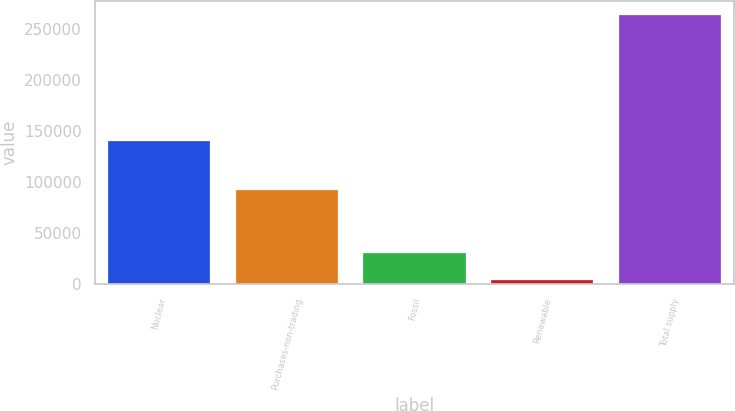<chart> <loc_0><loc_0><loc_500><loc_500><bar_chart><fcel>Nuclear<fcel>Purchases-non-trading<fcel>Fossil<fcel>Renewable<fcel>Total supply<nl><fcel>139862<fcel>91994<fcel>30040.6<fcel>4079<fcel>263695<nl></chart> 